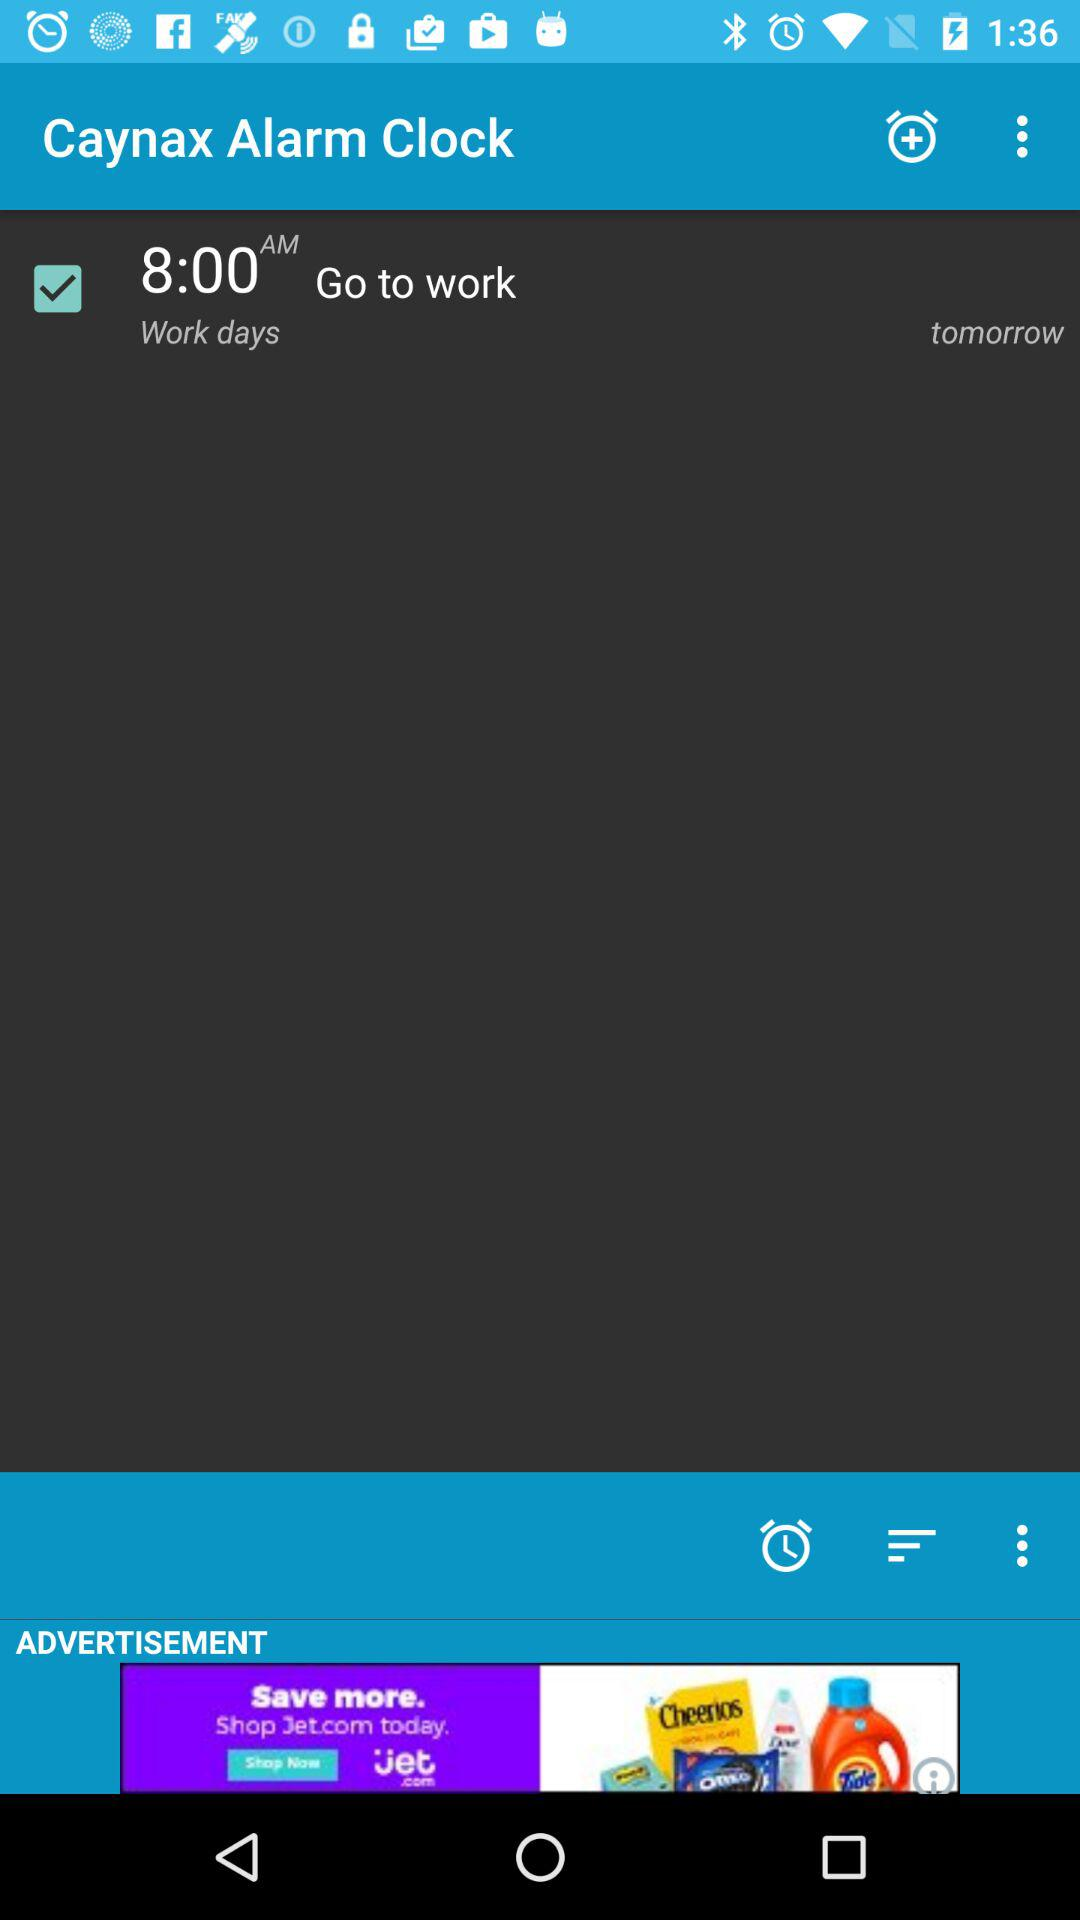What is the alarm time? The alarm time is 8:00 AM. 